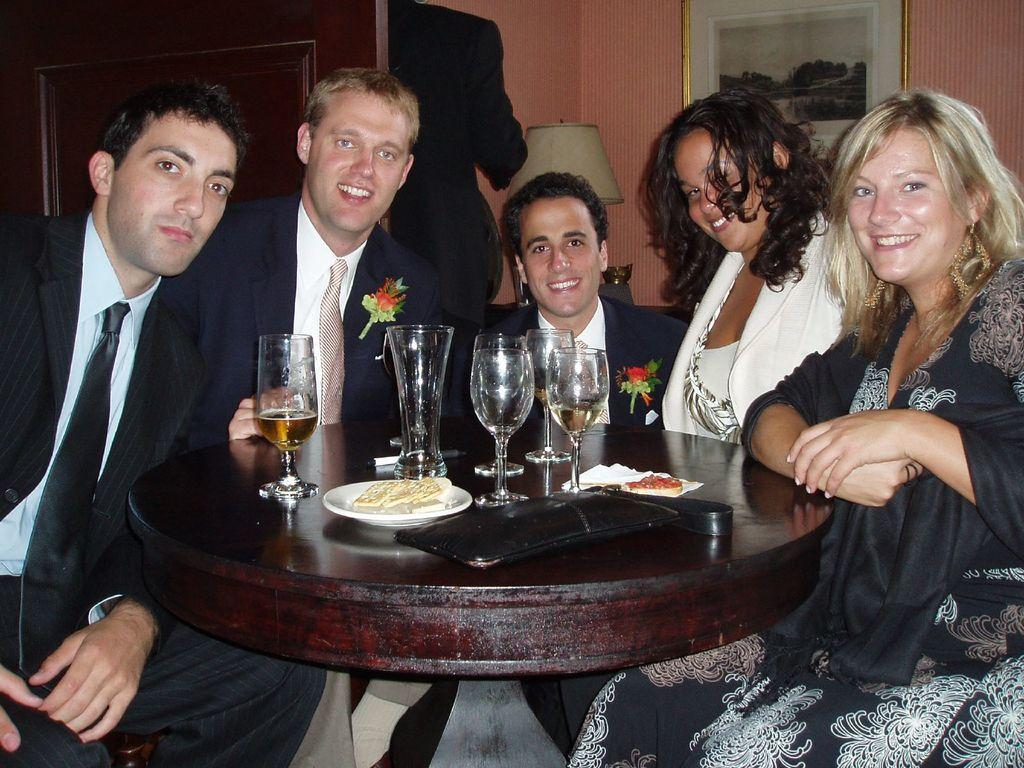How many people are in the image? There is a group of people in the image, but the exact number is not specified. What are the people doing in the image? The people are sitting around a table in the image. What objects can be seen on the table in the image? There are glasses, food on plates, and a pouch present on the table in the image. What type of heart-shaped development can be seen in the image? There is no heart-shaped development present in the image. What kind of paste is being used by the people in the image? There is no paste visible in the image; the people are sitting around a table with glasses, food on plates, and a pouch. 